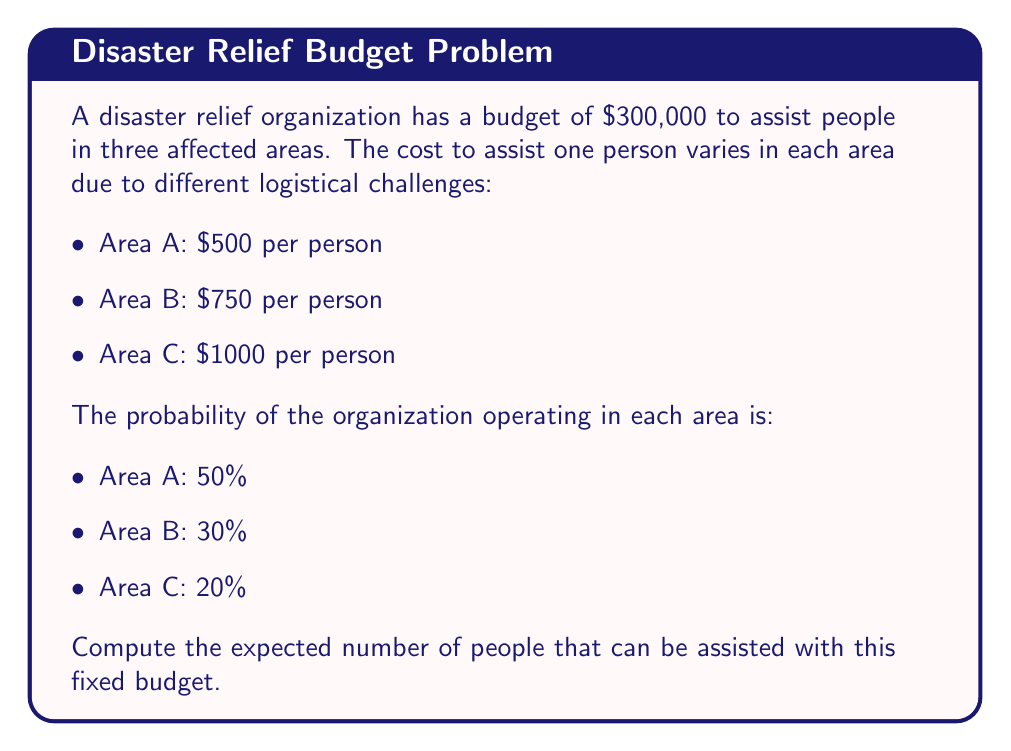Show me your answer to this math problem. To solve this problem, we'll follow these steps:

1) First, let's calculate the number of people that can be assisted in each area with the given budget:

   Area A: $\frac{300000}{500} = 600$ people
   Area B: $\frac{300000}{750} = 400$ people
   Area C: $\frac{300000}{1000} = 300$ people

2) Now, we'll use the formula for expected value:

   $E(X) = \sum_{i=1}^n x_i \cdot p_i$

   Where $x_i$ is the number of people that can be assisted in each area, and $p_i$ is the probability of operating in that area.

3) Let's substitute the values:

   $E(X) = 600 \cdot 0.5 + 400 \cdot 0.3 + 300 \cdot 0.2$

4) Now we can calculate:

   $E(X) = 300 + 120 + 60 = 480$

Therefore, the expected number of people that can be assisted is 480.
Answer: 480 people 